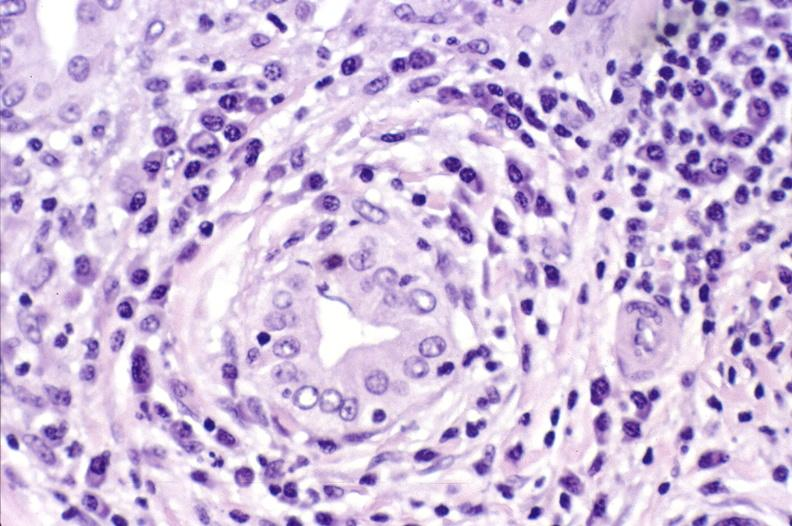s slide present?
Answer the question using a single word or phrase. No 